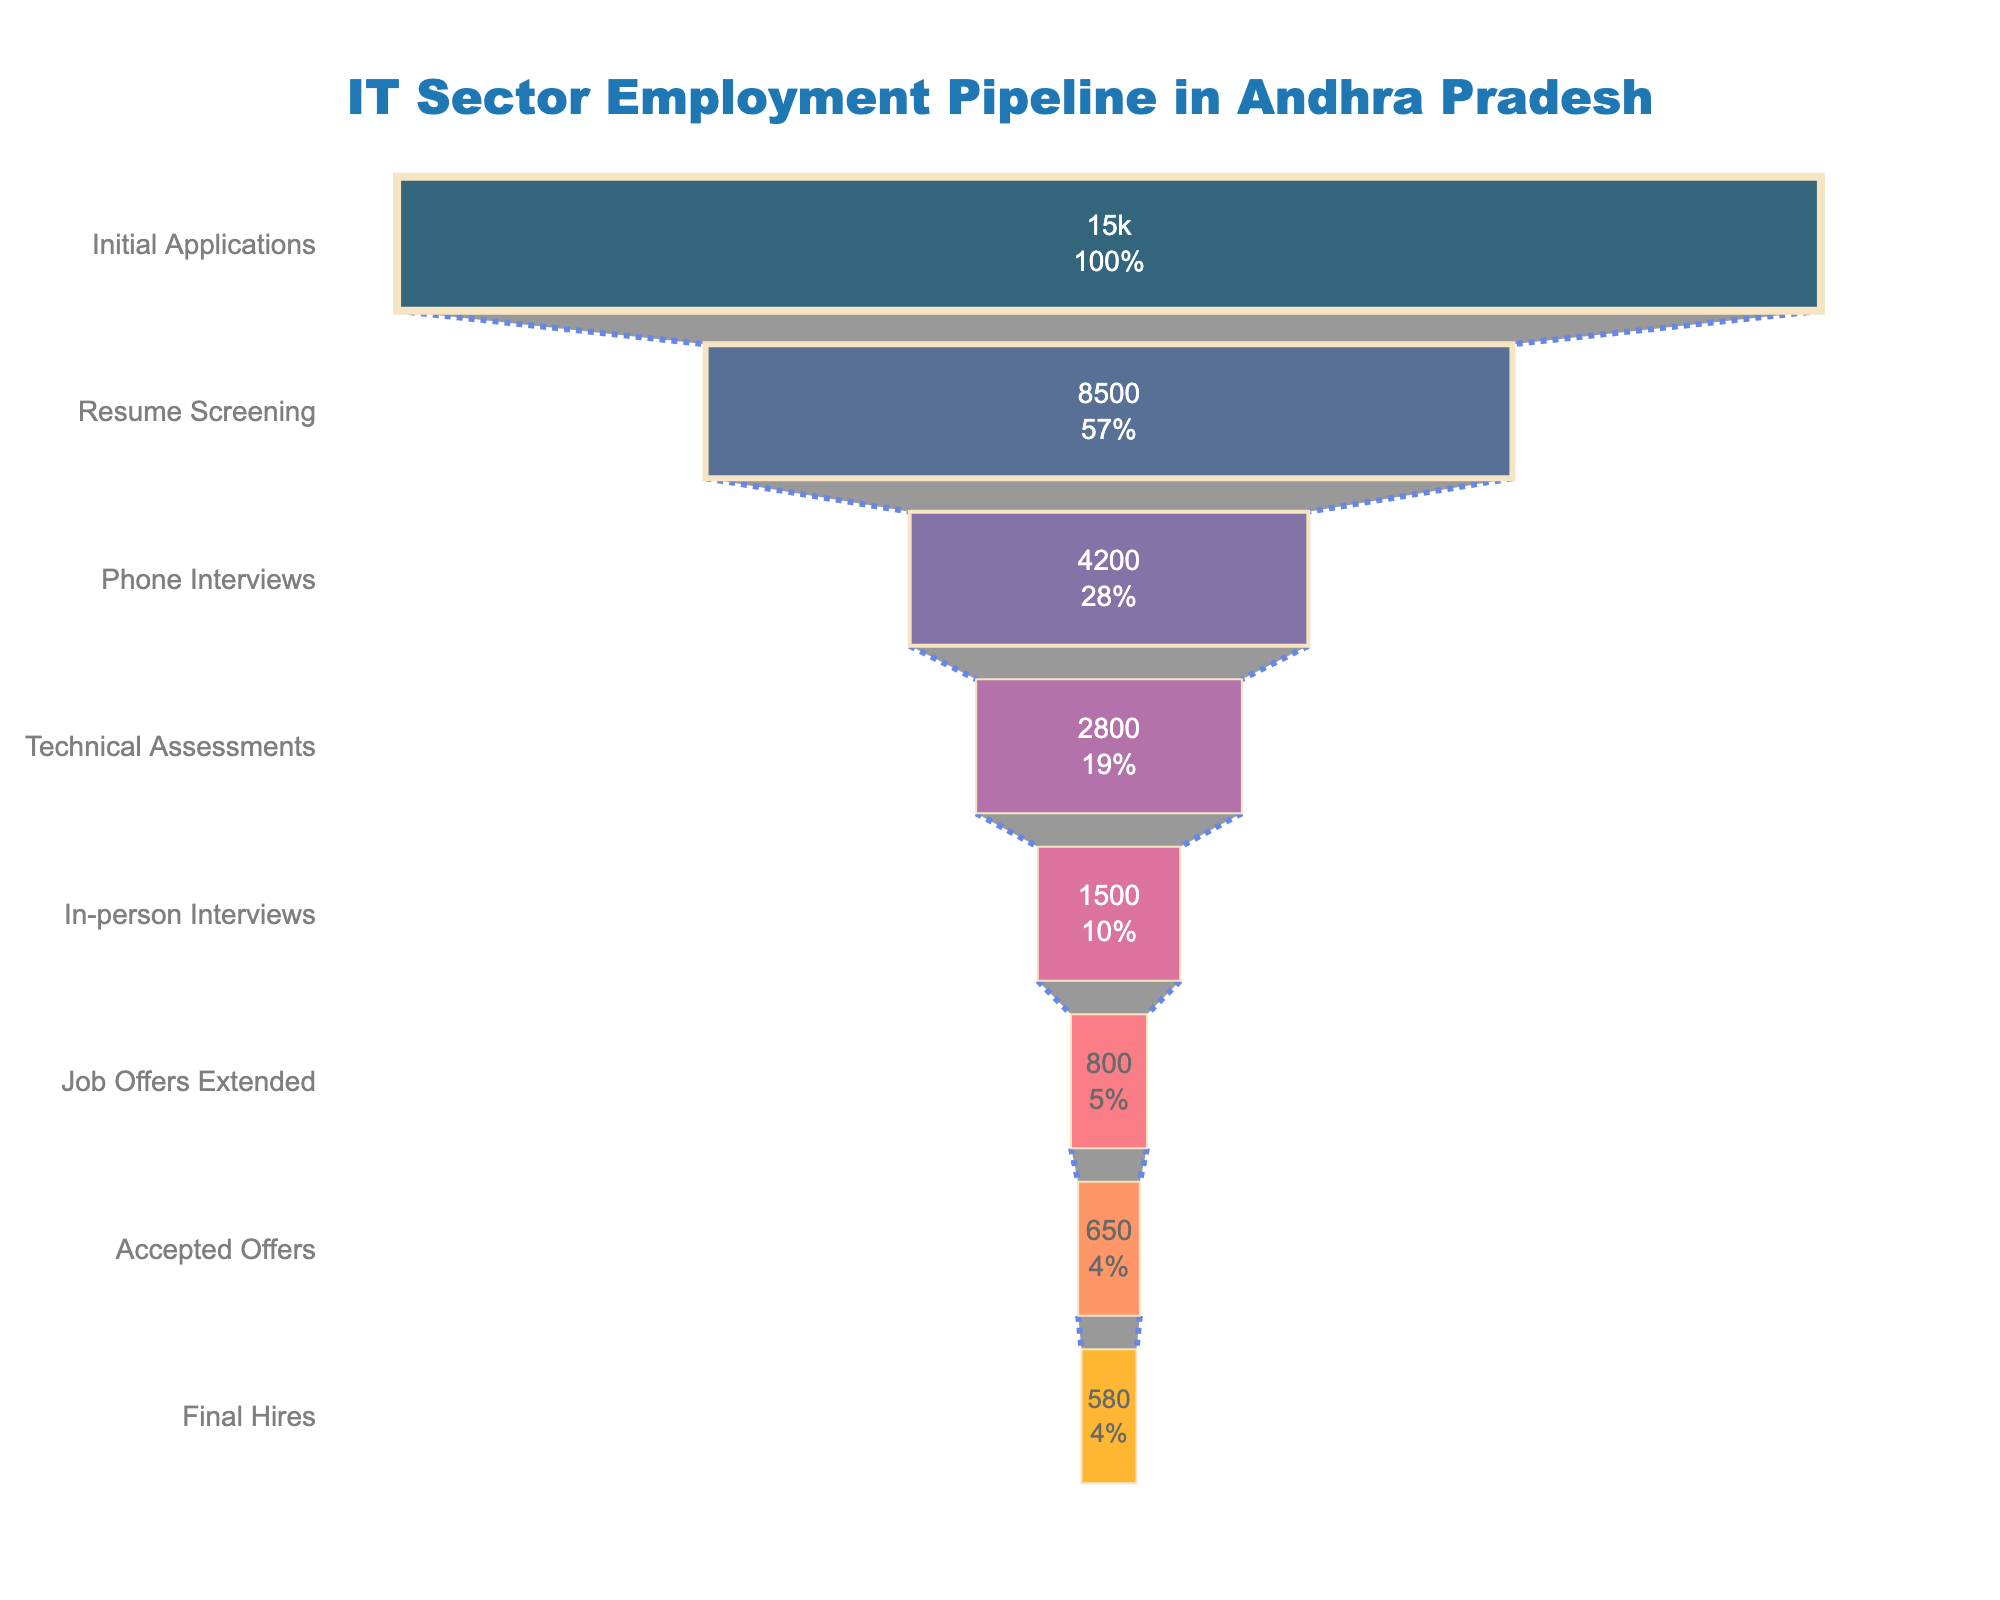What's the title of the funnel chart? At the top of the chart, the title is displayed. The specific font used further highlights it.
Answer: IT Sector Employment Pipeline in Andhra Pradesh How many applicants made it to the resume screening stage? The value for the "Resume Screening" stage is directly listed in the chart.
Answer: 8500 What percentage of the initial applications reached the phone interviews stage? The number of initial applications is 15000 and the number of phone interviews conducted is 4200. To find the percentage: (4200/15000) * 100%.
Answer: 28% How many stages are there from initial applications to final hires? Count the distinct stages plotted along the y-axis.
Answer: 8 What is the drop-off from the phone interviews to the technical assessments? Subtract the number of applicants from the technical assessments stage from the phone interviews stage: 4200 - 2800.
Answer: 1400 How many more applicants were there in the technical assessments stage compared to the in-person interviews stage? Subtract the number of in-person interviews from the technical assessments: 2800 - 1500.
Answer: 1300 What percentage of job offers were accepted? Divide the accepted offers by the job offers extended and multiply by 100: (650/800) * 100%.
Answer: 81.25% How many applicants were extended job offers but did not accept them? Subtract the number of accepted offers from the job offers extended: 800 - 650.
Answer: 150 Is the percentage drop larger between the resume screening and phone interviews or between technical assessments and in-person interviews? Calculate the percentage drop between resume screening (8500) and phone interviews (4200): ((8500 - 4200) / 8500) * 100% ≈ 50.59%, and between technical assessments (2800) and in-person interviews (1500): ((2800 - 1500) / 2800) * 100% ≈ 46.43%. Compare the two percentages.
Answer: Resume screening to phone interviews How many more applicants reached the final hires stage compared to those who accepted offers? Subtract the number at the final hires stage from the accepted offers: 650 - 580.
Answer: 70 